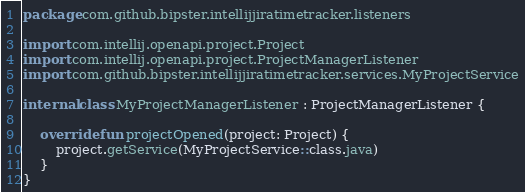<code> <loc_0><loc_0><loc_500><loc_500><_Kotlin_>package com.github.bipster.intellijjiratimetracker.listeners

import com.intellij.openapi.project.Project
import com.intellij.openapi.project.ProjectManagerListener
import com.github.bipster.intellijjiratimetracker.services.MyProjectService

internal class MyProjectManagerListener : ProjectManagerListener {

    override fun projectOpened(project: Project) {
        project.getService(MyProjectService::class.java)
    }
}
</code> 